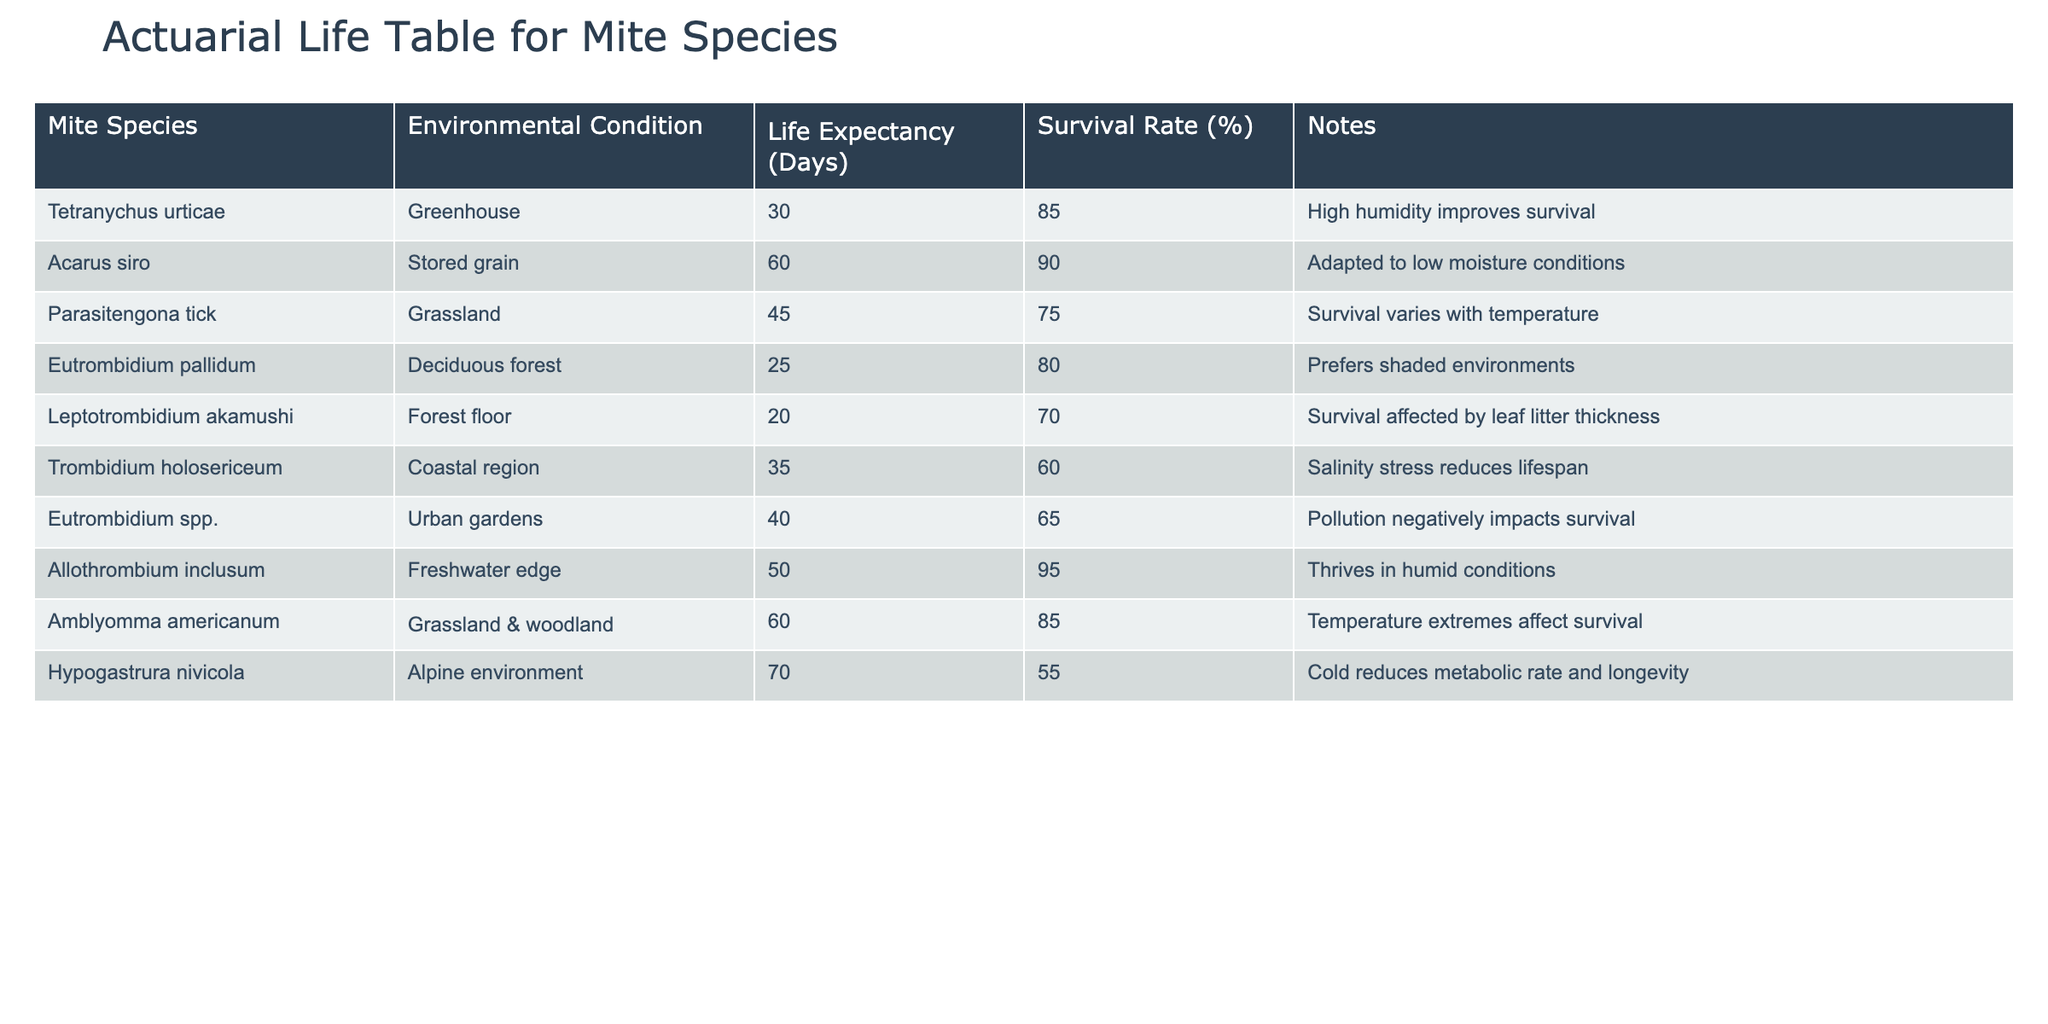What is the life expectancy of Acarus siro in stored grain? The life expectancy of Acarus siro is listed in the table under the "Life Expectancy (Days)" column. It is shown as 60 days.
Answer: 60 days Which mite species has the highest survival rate and what is it? By examining the "Survival Rate (%)" column, Allothrombium inclusum has the highest survival rate at 95%.
Answer: Allothrombium inclusum, 95% What is the average life expectancy of mites in urban gardens and greenhouses? The life expectancies for Eutrombidium spp. in urban gardens and Tetranychus urticae in greenhouses are 40 days and 30 days, respectively. The average is (40 + 30) / 2 = 35 days.
Answer: 35 days Does Hypogastrura nivicola have a longer life expectancy than Eutrombidium pallidum? Looking at the "Life Expectancy (Days)" column, Hypogastrura nivicola has a life expectancy of 70 days, which is longer than Eutrombidium pallidum's 25 days. Therefore, it is true.
Answer: Yes Which environmental condition significantly affects the survival of Leptotrombidium akamushi? The notes state that the survival of Leptotrombidium akamushi is affected by leaf litter thickness in the forest floor environment.
Answer: Leaf litter thickness What is the total survival rate of Amblyomma americanum and Parasitengona tick? Amblyomma americanum has a survival rate of 85%, and Parasitengona tick has a survival rate of 75%. Adding them together gives 85 + 75 = 160%.
Answer: 160% Which mite species can be found in coastal regions and what is its survival rate? The table indicates that Trombidium holosericeum can be found in coastal regions and has a survival rate of 60%.
Answer: Trombidium holosericeum, 60% Is Eutrombidium pallidum's life expectancy lower than that of Tetranychus urticae? The life expectancy of Eutrombidium pallidum is 25 days, while Tetranychus urticae's is 30 days. Since 25 is less than 30, the answer is yes.
Answer: Yes What environmental conditions increase the survival of Acarus siro? The table notes that Acarus siro is adapted to low moisture conditions, which suggests it thrives when moisture is low.
Answer: Low moisture conditions 